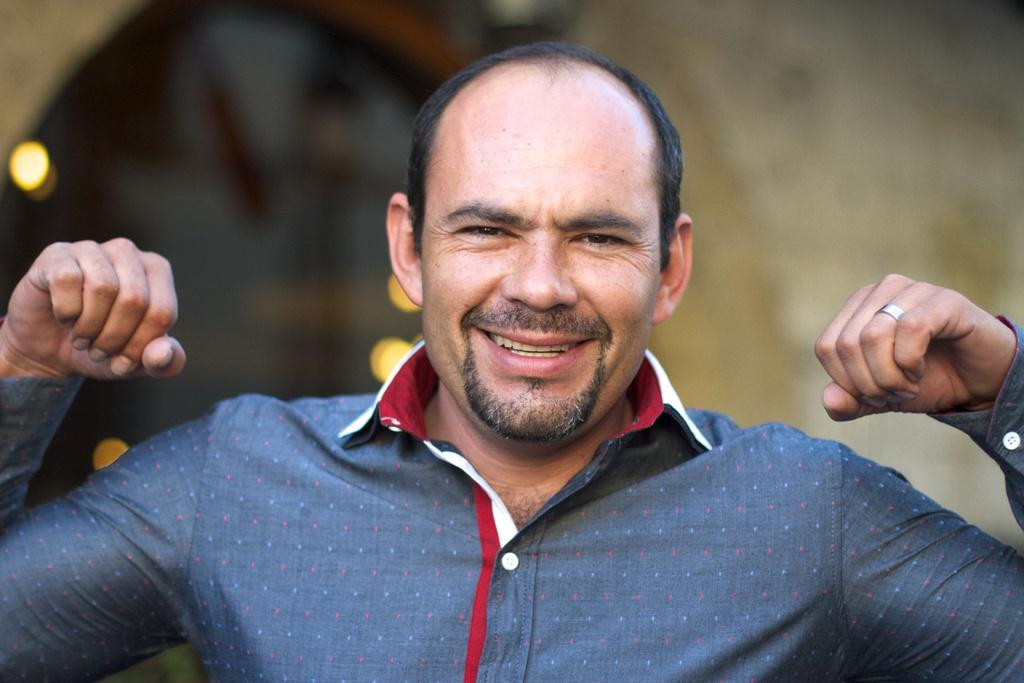What is the main subject of the image? There is a person in the image. What is the person's facial expression? The person is smiling. Can you describe the background of the image? The background of the image is blurry. What type of linen can be seen blowing in the wind in the image? There is no linen or wind present in the image; it features a person with a blurry background. 